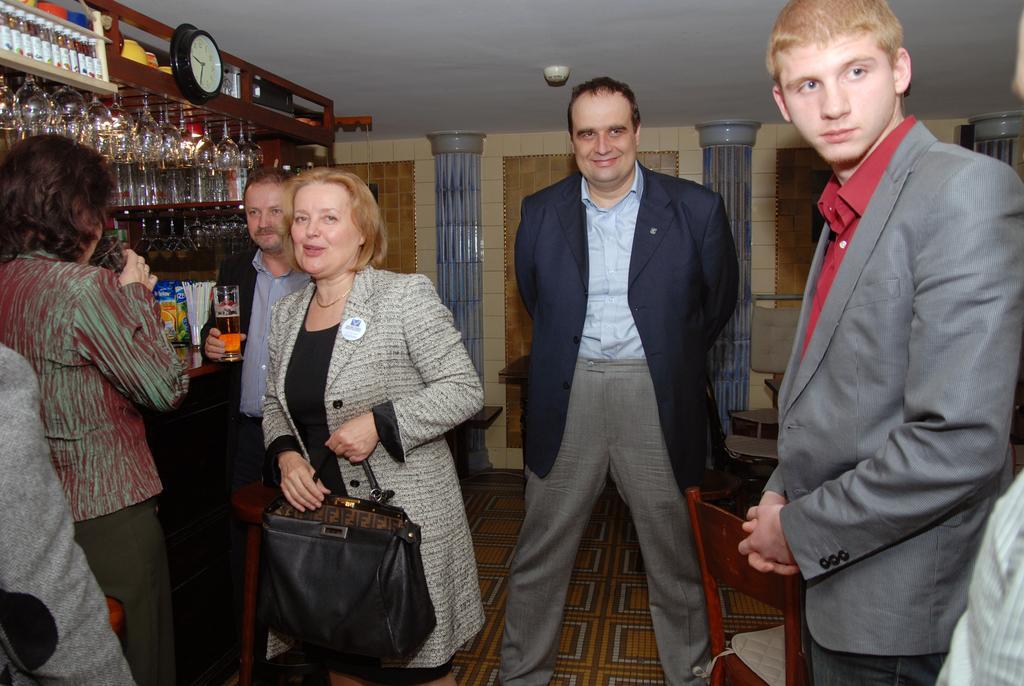Can you describe this image briefly? In this image we can see people, chairs, floor, bottles, glasses, clock, wall, and other objects. 